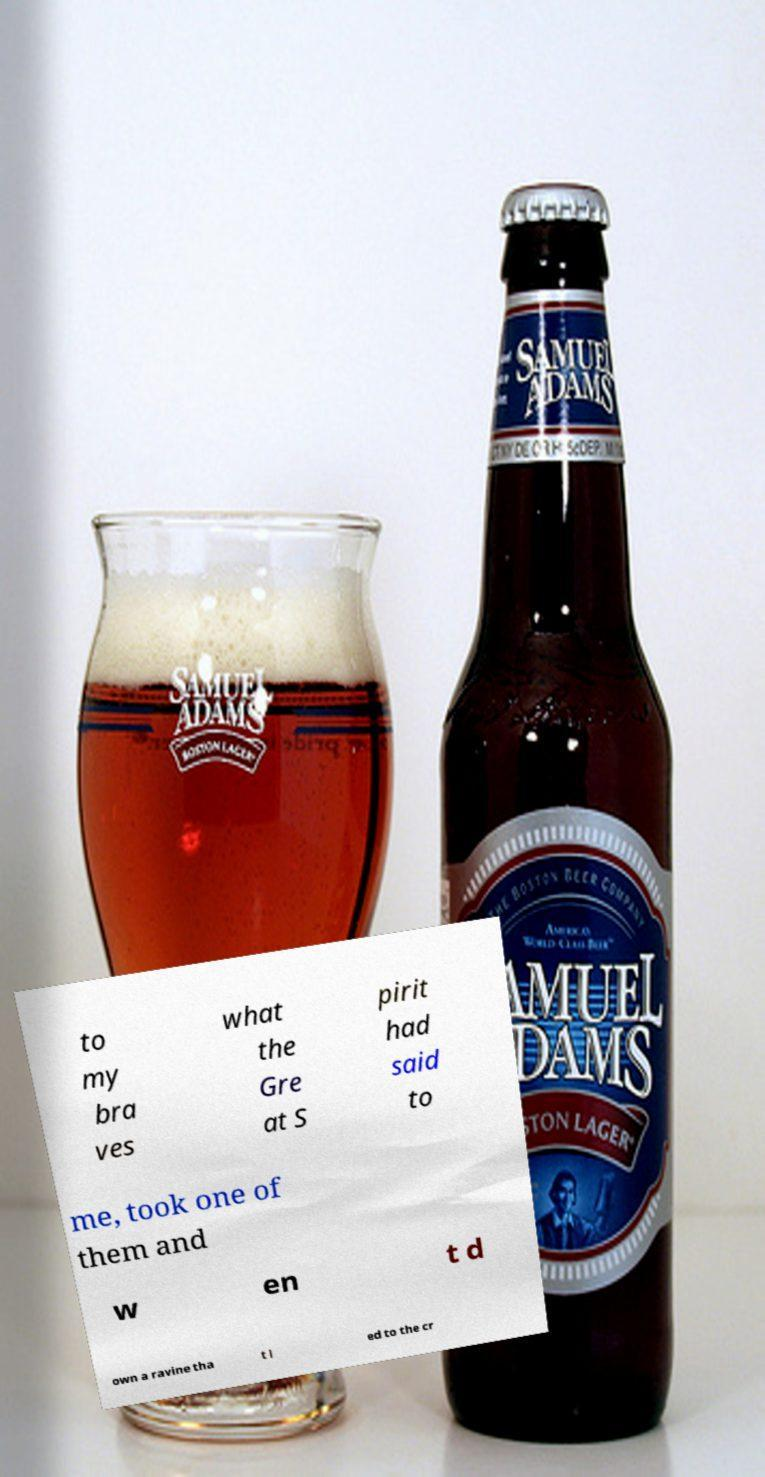Can you accurately transcribe the text from the provided image for me? to my bra ves what the Gre at S pirit had said to me, took one of them and w en t d own a ravine tha t l ed to the cr 